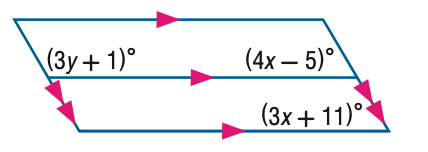Answer the mathemtical geometry problem and directly provide the correct option letter.
Question: Find x in the figure.
Choices: A: 12 B: 16 C: 20 D: 32 B 